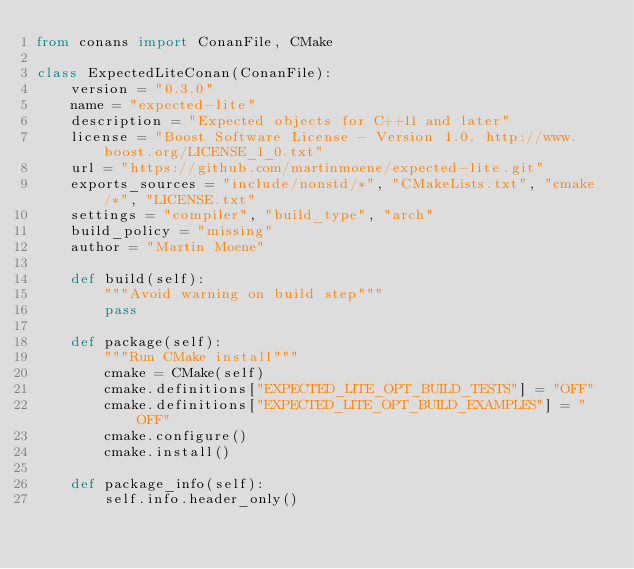<code> <loc_0><loc_0><loc_500><loc_500><_Python_>from conans import ConanFile, CMake

class ExpectedLiteConan(ConanFile):
    version = "0.3.0"
    name = "expected-lite"
    description = "Expected objects for C++11 and later"
    license = "Boost Software License - Version 1.0. http://www.boost.org/LICENSE_1_0.txt"
    url = "https://github.com/martinmoene/expected-lite.git"
    exports_sources = "include/nonstd/*", "CMakeLists.txt", "cmake/*", "LICENSE.txt"
    settings = "compiler", "build_type", "arch"
    build_policy = "missing"
    author = "Martin Moene"

    def build(self):
        """Avoid warning on build step"""
        pass

    def package(self):
        """Run CMake install"""
        cmake = CMake(self)
        cmake.definitions["EXPECTED_LITE_OPT_BUILD_TESTS"] = "OFF"
        cmake.definitions["EXPECTED_LITE_OPT_BUILD_EXAMPLES"] = "OFF"
        cmake.configure()
        cmake.install()

    def package_info(self):
        self.info.header_only()
</code> 